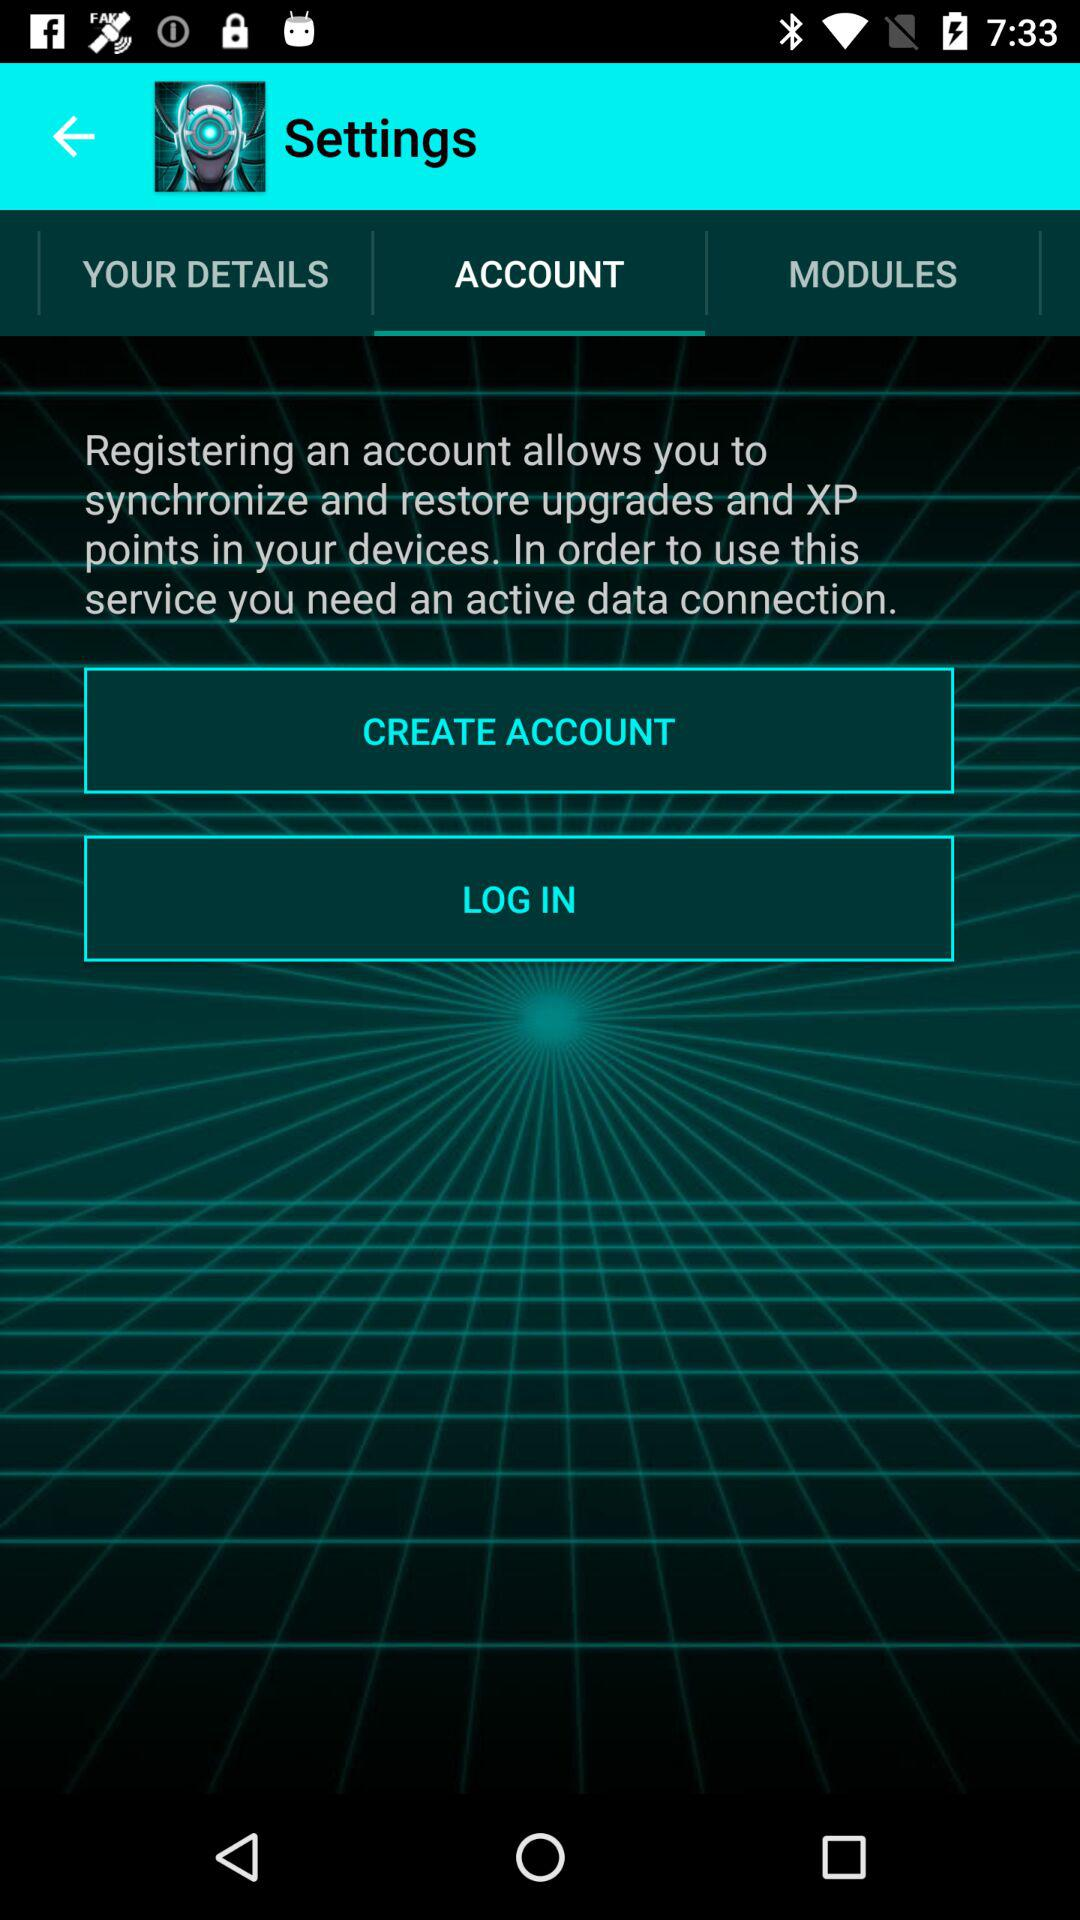Which tab is selected? The selected tab is "ACCOUNT". 